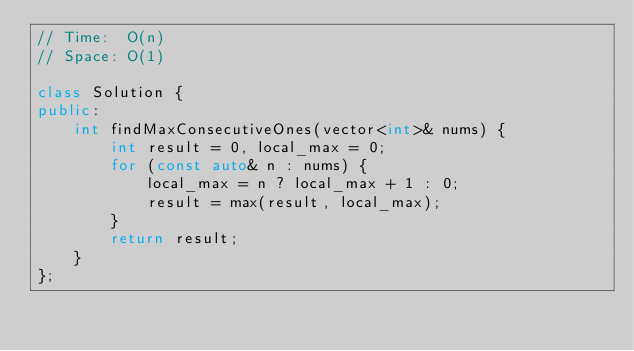Convert code to text. <code><loc_0><loc_0><loc_500><loc_500><_C++_>// Time:  O(n)
// Space: O(1)

class Solution {
public:
    int findMaxConsecutiveOnes(vector<int>& nums) {
        int result = 0, local_max = 0;
        for (const auto& n : nums) {
            local_max = n ? local_max + 1 : 0;
            result = max(result, local_max);
        }
        return result;
    }
};
</code> 